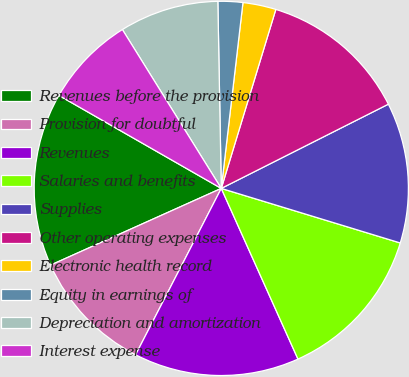<chart> <loc_0><loc_0><loc_500><loc_500><pie_chart><fcel>Revenues before the provision<fcel>Provision for doubtful<fcel>Revenues<fcel>Salaries and benefits<fcel>Supplies<fcel>Other operating expenses<fcel>Electronic health record<fcel>Equity in earnings of<fcel>Depreciation and amortization<fcel>Interest expense<nl><fcel>15.0%<fcel>10.71%<fcel>14.29%<fcel>13.57%<fcel>12.14%<fcel>12.86%<fcel>2.86%<fcel>2.14%<fcel>8.57%<fcel>7.86%<nl></chart> 